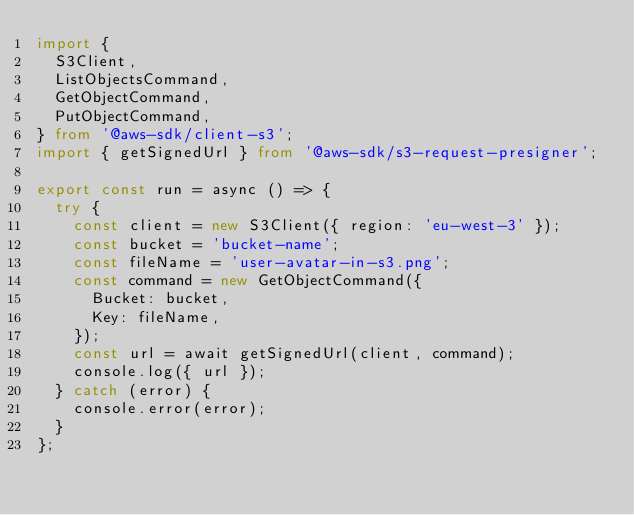<code> <loc_0><loc_0><loc_500><loc_500><_TypeScript_>import {
  S3Client,
  ListObjectsCommand,
  GetObjectCommand,
  PutObjectCommand,
} from '@aws-sdk/client-s3';
import { getSignedUrl } from '@aws-sdk/s3-request-presigner';

export const run = async () => {
  try {
    const client = new S3Client({ region: 'eu-west-3' });
    const bucket = 'bucket-name';
    const fileName = 'user-avatar-in-s3.png';
    const command = new GetObjectCommand({
      Bucket: bucket,
      Key: fileName,
    });
    const url = await getSignedUrl(client, command);
    console.log({ url });
  } catch (error) {
    console.error(error);
  }
};
</code> 